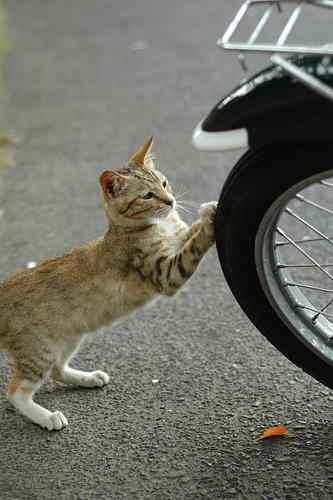What could potentially puncture the tire?

Choices:
A) fur
B) claws
C) eyes
D) ears claws 